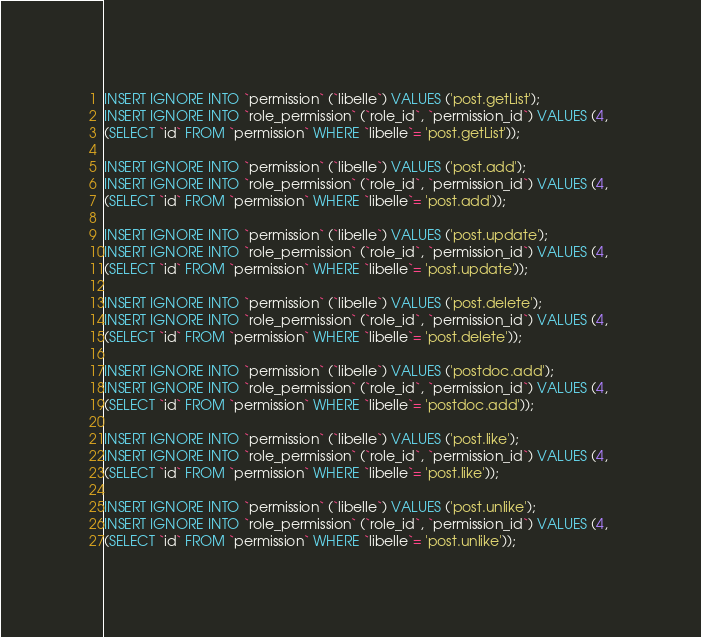Convert code to text. <code><loc_0><loc_0><loc_500><loc_500><_SQL_>INSERT IGNORE INTO `permission` (`libelle`) VALUES ('post.getList');
INSERT IGNORE INTO `role_permission` (`role_id`, `permission_id`) VALUES (4, 
(SELECT `id` FROM `permission` WHERE `libelle`= 'post.getList'));

INSERT IGNORE INTO `permission` (`libelle`) VALUES ('post.add');
INSERT IGNORE INTO `role_permission` (`role_id`, `permission_id`) VALUES (4, 
(SELECT `id` FROM `permission` WHERE `libelle`= 'post.add'));

INSERT IGNORE INTO `permission` (`libelle`) VALUES ('post.update');
INSERT IGNORE INTO `role_permission` (`role_id`, `permission_id`) VALUES (4, 
(SELECT `id` FROM `permission` WHERE `libelle`= 'post.update'));

INSERT IGNORE INTO `permission` (`libelle`) VALUES ('post.delete');
INSERT IGNORE INTO `role_permission` (`role_id`, `permission_id`) VALUES (4, 
(SELECT `id` FROM `permission` WHERE `libelle`= 'post.delete'));

INSERT IGNORE INTO `permission` (`libelle`) VALUES ('postdoc.add');
INSERT IGNORE INTO `role_permission` (`role_id`, `permission_id`) VALUES (4, 
(SELECT `id` FROM `permission` WHERE `libelle`= 'postdoc.add'));

INSERT IGNORE INTO `permission` (`libelle`) VALUES ('post.like');
INSERT IGNORE INTO `role_permission` (`role_id`, `permission_id`) VALUES (4, 
(SELECT `id` FROM `permission` WHERE `libelle`= 'post.like'));

INSERT IGNORE INTO `permission` (`libelle`) VALUES ('post.unlike');
INSERT IGNORE INTO `role_permission` (`role_id`, `permission_id`) VALUES (4, 
(SELECT `id` FROM `permission` WHERE `libelle`= 'post.unlike'));
</code> 